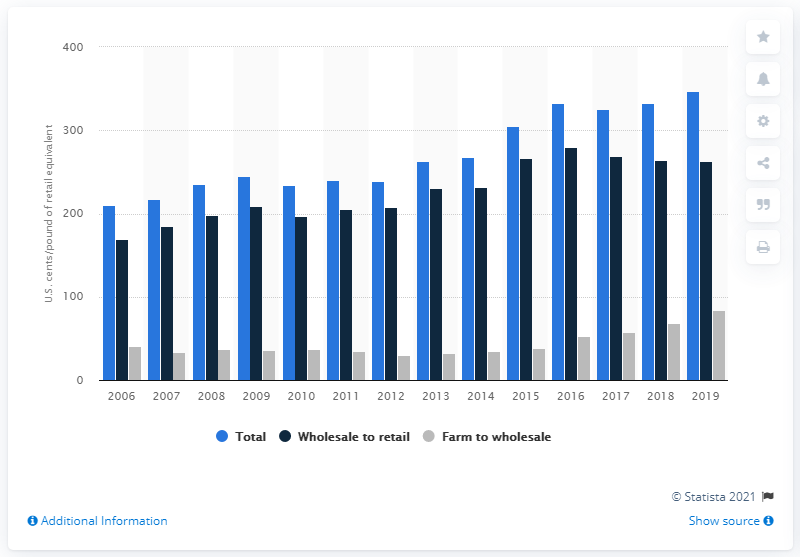Give some essential details in this illustration. In 2017, the price spread between the wholesale and retail prices of beef in the United States was approximately 268.5 cents per pound of retail equivalent. 